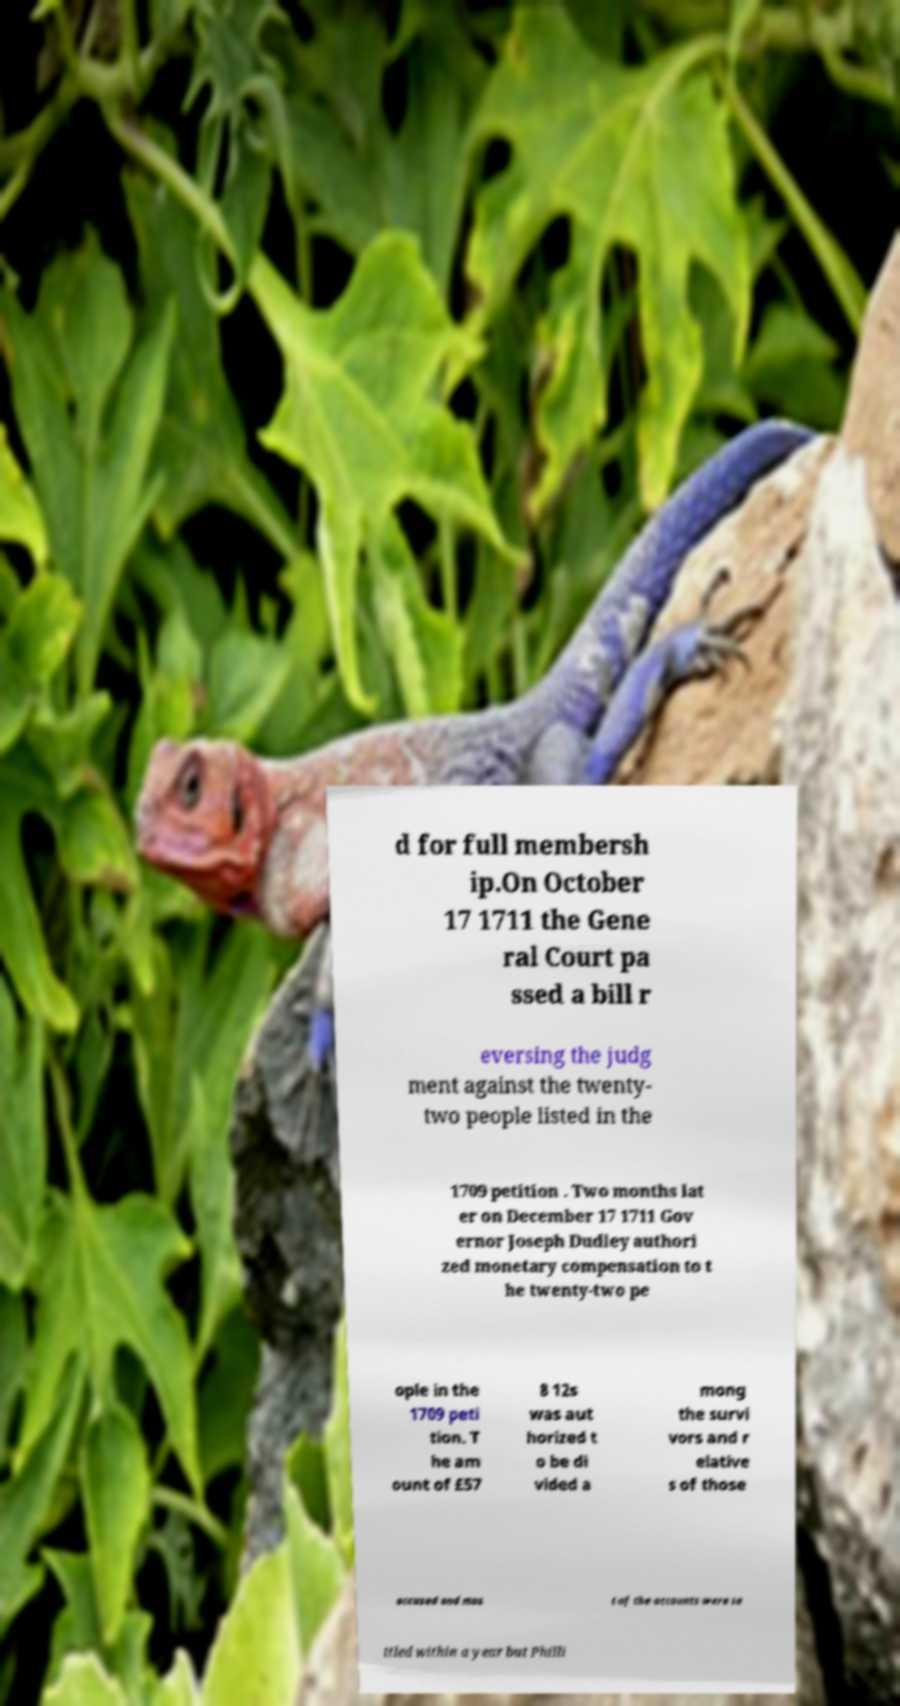Please identify and transcribe the text found in this image. d for full membersh ip.On October 17 1711 the Gene ral Court pa ssed a bill r eversing the judg ment against the twenty- two people listed in the 1709 petition . Two months lat er on December 17 1711 Gov ernor Joseph Dudley authori zed monetary compensation to t he twenty-two pe ople in the 1709 peti tion. T he am ount of £57 8 12s was aut horized t o be di vided a mong the survi vors and r elative s of those accused and mos t of the accounts were se ttled within a year but Philli 